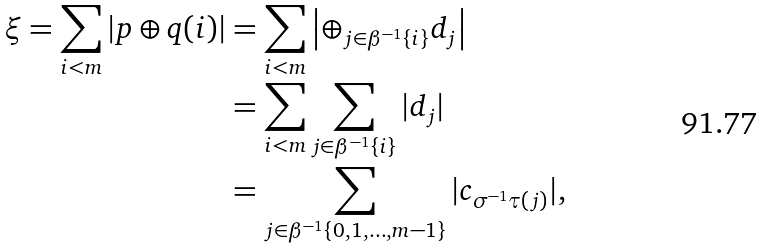Convert formula to latex. <formula><loc_0><loc_0><loc_500><loc_500>\xi = \sum _ { i < m } | p \oplus q ( i ) | & = \sum _ { i < m } \left | \oplus _ { j \in { \beta } ^ { - 1 } \{ i \} } d _ { j } \right | \\ & = \sum _ { i < m } \sum _ { j \in { \beta } ^ { - 1 } \{ i \} } | d _ { j } | \\ & = \sum _ { j \in { \beta } ^ { - 1 } \{ 0 , 1 , \dots , m - 1 \} } | c _ { \sigma ^ { - 1 } \tau ( j ) } | ,</formula> 